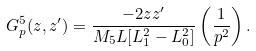<formula> <loc_0><loc_0><loc_500><loc_500>G ^ { 5 } _ { p } ( z , z ^ { \prime } ) = \frac { - 2 z z ^ { \prime } } { M _ { 5 } L [ L _ { 1 } ^ { 2 } - L _ { 0 } ^ { 2 } ] } \left ( \frac { 1 } { p ^ { 2 } } \right ) .</formula> 